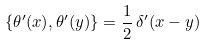Convert formula to latex. <formula><loc_0><loc_0><loc_500><loc_500>\{ \theta ^ { \prime } ( x ) , \theta ^ { \prime } ( y ) \} = \frac { 1 } { 2 } \, \delta ^ { \prime } ( x - y )</formula> 